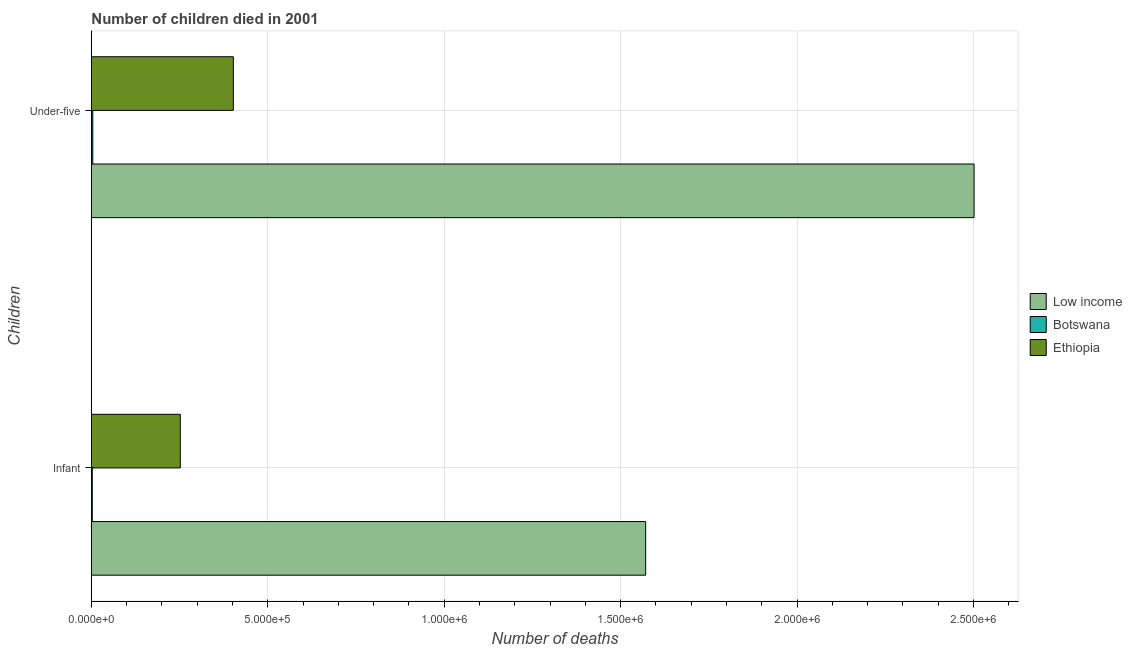How many different coloured bars are there?
Give a very brief answer. 3. How many bars are there on the 2nd tick from the top?
Keep it short and to the point. 3. What is the label of the 1st group of bars from the top?
Offer a terse response. Under-five. What is the number of under-five deaths in Low income?
Your answer should be compact. 2.50e+06. Across all countries, what is the maximum number of infant deaths?
Offer a terse response. 1.57e+06. Across all countries, what is the minimum number of under-five deaths?
Keep it short and to the point. 3852. In which country was the number of under-five deaths maximum?
Provide a succinct answer. Low income. In which country was the number of under-five deaths minimum?
Offer a very short reply. Botswana. What is the total number of infant deaths in the graph?
Offer a very short reply. 1.83e+06. What is the difference between the number of under-five deaths in Ethiopia and that in Botswana?
Your answer should be compact. 3.98e+05. What is the difference between the number of infant deaths in Ethiopia and the number of under-five deaths in Botswana?
Provide a short and direct response. 2.48e+05. What is the average number of infant deaths per country?
Your answer should be very brief. 6.08e+05. What is the difference between the number of under-five deaths and number of infant deaths in Botswana?
Ensure brevity in your answer.  1445. In how many countries, is the number of under-five deaths greater than 700000 ?
Your answer should be very brief. 1. What is the ratio of the number of infant deaths in Ethiopia to that in Botswana?
Keep it short and to the point. 104.65. What does the 1st bar from the top in Infant represents?
Give a very brief answer. Ethiopia. How many bars are there?
Ensure brevity in your answer.  6. Does the graph contain any zero values?
Offer a very short reply. No. Does the graph contain grids?
Your answer should be compact. Yes. Where does the legend appear in the graph?
Your response must be concise. Center right. How are the legend labels stacked?
Offer a terse response. Vertical. What is the title of the graph?
Your answer should be compact. Number of children died in 2001. Does "Guyana" appear as one of the legend labels in the graph?
Offer a very short reply. No. What is the label or title of the X-axis?
Your answer should be compact. Number of deaths. What is the label or title of the Y-axis?
Offer a terse response. Children. What is the Number of deaths of Low income in Infant?
Ensure brevity in your answer.  1.57e+06. What is the Number of deaths of Botswana in Infant?
Ensure brevity in your answer.  2407. What is the Number of deaths in Ethiopia in Infant?
Make the answer very short. 2.52e+05. What is the Number of deaths in Low income in Under-five?
Provide a short and direct response. 2.50e+06. What is the Number of deaths of Botswana in Under-five?
Your answer should be compact. 3852. What is the Number of deaths in Ethiopia in Under-five?
Your answer should be very brief. 4.02e+05. Across all Children, what is the maximum Number of deaths of Low income?
Your answer should be very brief. 2.50e+06. Across all Children, what is the maximum Number of deaths of Botswana?
Keep it short and to the point. 3852. Across all Children, what is the maximum Number of deaths of Ethiopia?
Keep it short and to the point. 4.02e+05. Across all Children, what is the minimum Number of deaths of Low income?
Keep it short and to the point. 1.57e+06. Across all Children, what is the minimum Number of deaths in Botswana?
Offer a very short reply. 2407. Across all Children, what is the minimum Number of deaths in Ethiopia?
Offer a terse response. 2.52e+05. What is the total Number of deaths in Low income in the graph?
Ensure brevity in your answer.  4.07e+06. What is the total Number of deaths in Botswana in the graph?
Provide a succinct answer. 6259. What is the total Number of deaths in Ethiopia in the graph?
Keep it short and to the point. 6.54e+05. What is the difference between the Number of deaths in Low income in Infant and that in Under-five?
Make the answer very short. -9.31e+05. What is the difference between the Number of deaths in Botswana in Infant and that in Under-five?
Give a very brief answer. -1445. What is the difference between the Number of deaths of Ethiopia in Infant and that in Under-five?
Provide a succinct answer. -1.50e+05. What is the difference between the Number of deaths of Low income in Infant and the Number of deaths of Botswana in Under-five?
Your answer should be very brief. 1.57e+06. What is the difference between the Number of deaths in Low income in Infant and the Number of deaths in Ethiopia in Under-five?
Give a very brief answer. 1.17e+06. What is the difference between the Number of deaths in Botswana in Infant and the Number of deaths in Ethiopia in Under-five?
Give a very brief answer. -4.00e+05. What is the average Number of deaths in Low income per Children?
Make the answer very short. 2.04e+06. What is the average Number of deaths of Botswana per Children?
Your response must be concise. 3129.5. What is the average Number of deaths in Ethiopia per Children?
Offer a very short reply. 3.27e+05. What is the difference between the Number of deaths in Low income and Number of deaths in Botswana in Infant?
Your response must be concise. 1.57e+06. What is the difference between the Number of deaths in Low income and Number of deaths in Ethiopia in Infant?
Keep it short and to the point. 1.32e+06. What is the difference between the Number of deaths of Botswana and Number of deaths of Ethiopia in Infant?
Offer a very short reply. -2.49e+05. What is the difference between the Number of deaths in Low income and Number of deaths in Botswana in Under-five?
Keep it short and to the point. 2.50e+06. What is the difference between the Number of deaths in Low income and Number of deaths in Ethiopia in Under-five?
Keep it short and to the point. 2.10e+06. What is the difference between the Number of deaths of Botswana and Number of deaths of Ethiopia in Under-five?
Keep it short and to the point. -3.98e+05. What is the ratio of the Number of deaths of Low income in Infant to that in Under-five?
Your answer should be compact. 0.63. What is the ratio of the Number of deaths of Botswana in Infant to that in Under-five?
Your response must be concise. 0.62. What is the ratio of the Number of deaths of Ethiopia in Infant to that in Under-five?
Make the answer very short. 0.63. What is the difference between the highest and the second highest Number of deaths in Low income?
Offer a terse response. 9.31e+05. What is the difference between the highest and the second highest Number of deaths of Botswana?
Provide a succinct answer. 1445. What is the difference between the highest and the second highest Number of deaths of Ethiopia?
Your answer should be very brief. 1.50e+05. What is the difference between the highest and the lowest Number of deaths of Low income?
Offer a terse response. 9.31e+05. What is the difference between the highest and the lowest Number of deaths in Botswana?
Keep it short and to the point. 1445. What is the difference between the highest and the lowest Number of deaths of Ethiopia?
Your answer should be compact. 1.50e+05. 